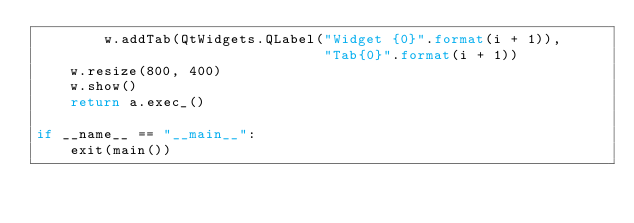<code> <loc_0><loc_0><loc_500><loc_500><_Python_>        w.addTab(QtWidgets.QLabel("Widget {0}".format(i + 1)),
                                  "Tab{0}".format(i + 1))
    w.resize(800, 400)
    w.show()
    return a.exec_()

if __name__ == "__main__":
    exit(main())
    
</code> 